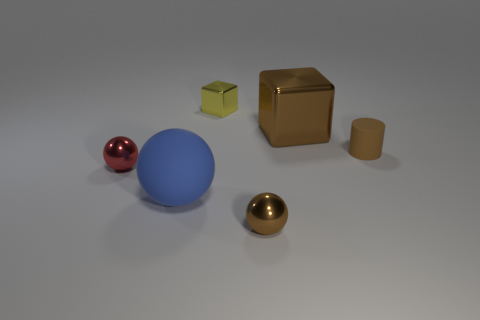Are there fewer large things than green rubber balls?
Provide a succinct answer. No. Are there any cylinders made of the same material as the blue ball?
Offer a very short reply. Yes. What is the shape of the tiny thing that is right of the large block?
Your answer should be very brief. Cylinder. There is a metal block that is to the right of the brown ball; does it have the same color as the small cylinder?
Give a very brief answer. Yes. Is the number of large metal things in front of the cylinder less than the number of large blue shiny blocks?
Your response must be concise. No. There is another tiny cube that is made of the same material as the brown cube; what is its color?
Provide a succinct answer. Yellow. What size is the matte object that is in front of the small brown rubber object?
Offer a very short reply. Large. Does the brown ball have the same material as the small red object?
Keep it short and to the point. Yes. There is a big shiny block to the right of the large object that is in front of the brown rubber thing; are there any tiny rubber cylinders that are in front of it?
Your answer should be very brief. Yes. What is the color of the big metal thing?
Your answer should be very brief. Brown. 